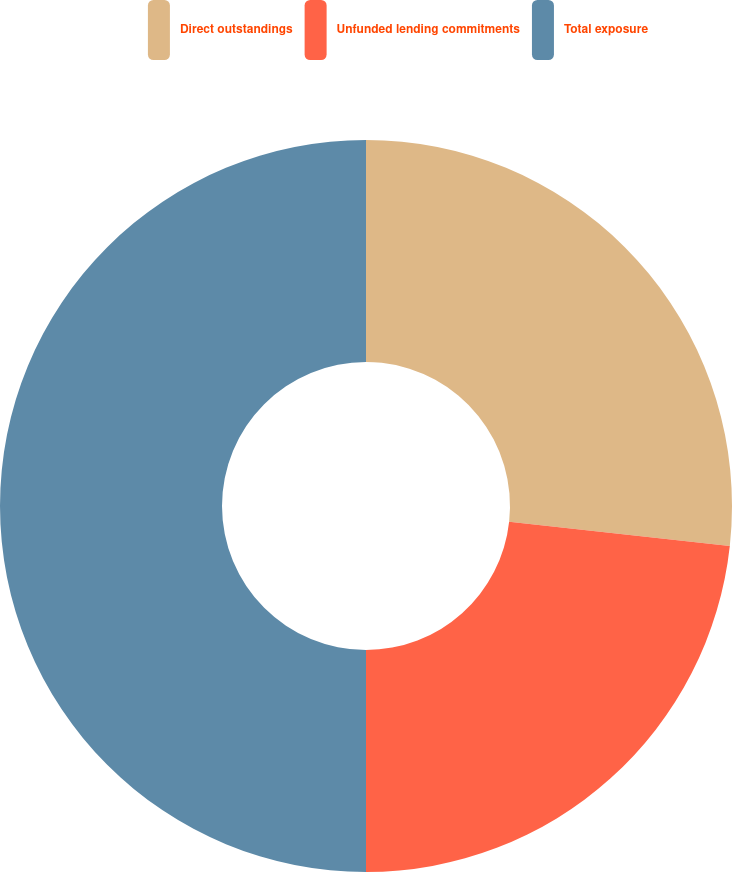Convert chart to OTSL. <chart><loc_0><loc_0><loc_500><loc_500><pie_chart><fcel>Direct outstandings<fcel>Unfunded lending commitments<fcel>Total exposure<nl><fcel>26.74%<fcel>23.26%<fcel>50.0%<nl></chart> 